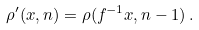<formula> <loc_0><loc_0><loc_500><loc_500>\rho ^ { \prime } ( x , n ) = \rho ( f ^ { - 1 } x , n - 1 ) \, .</formula> 